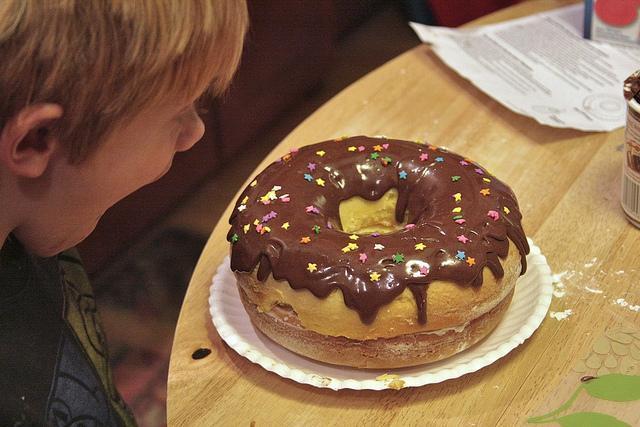Is the given caption "The person is touching the donut." fitting for the image?
Answer yes or no. No. 